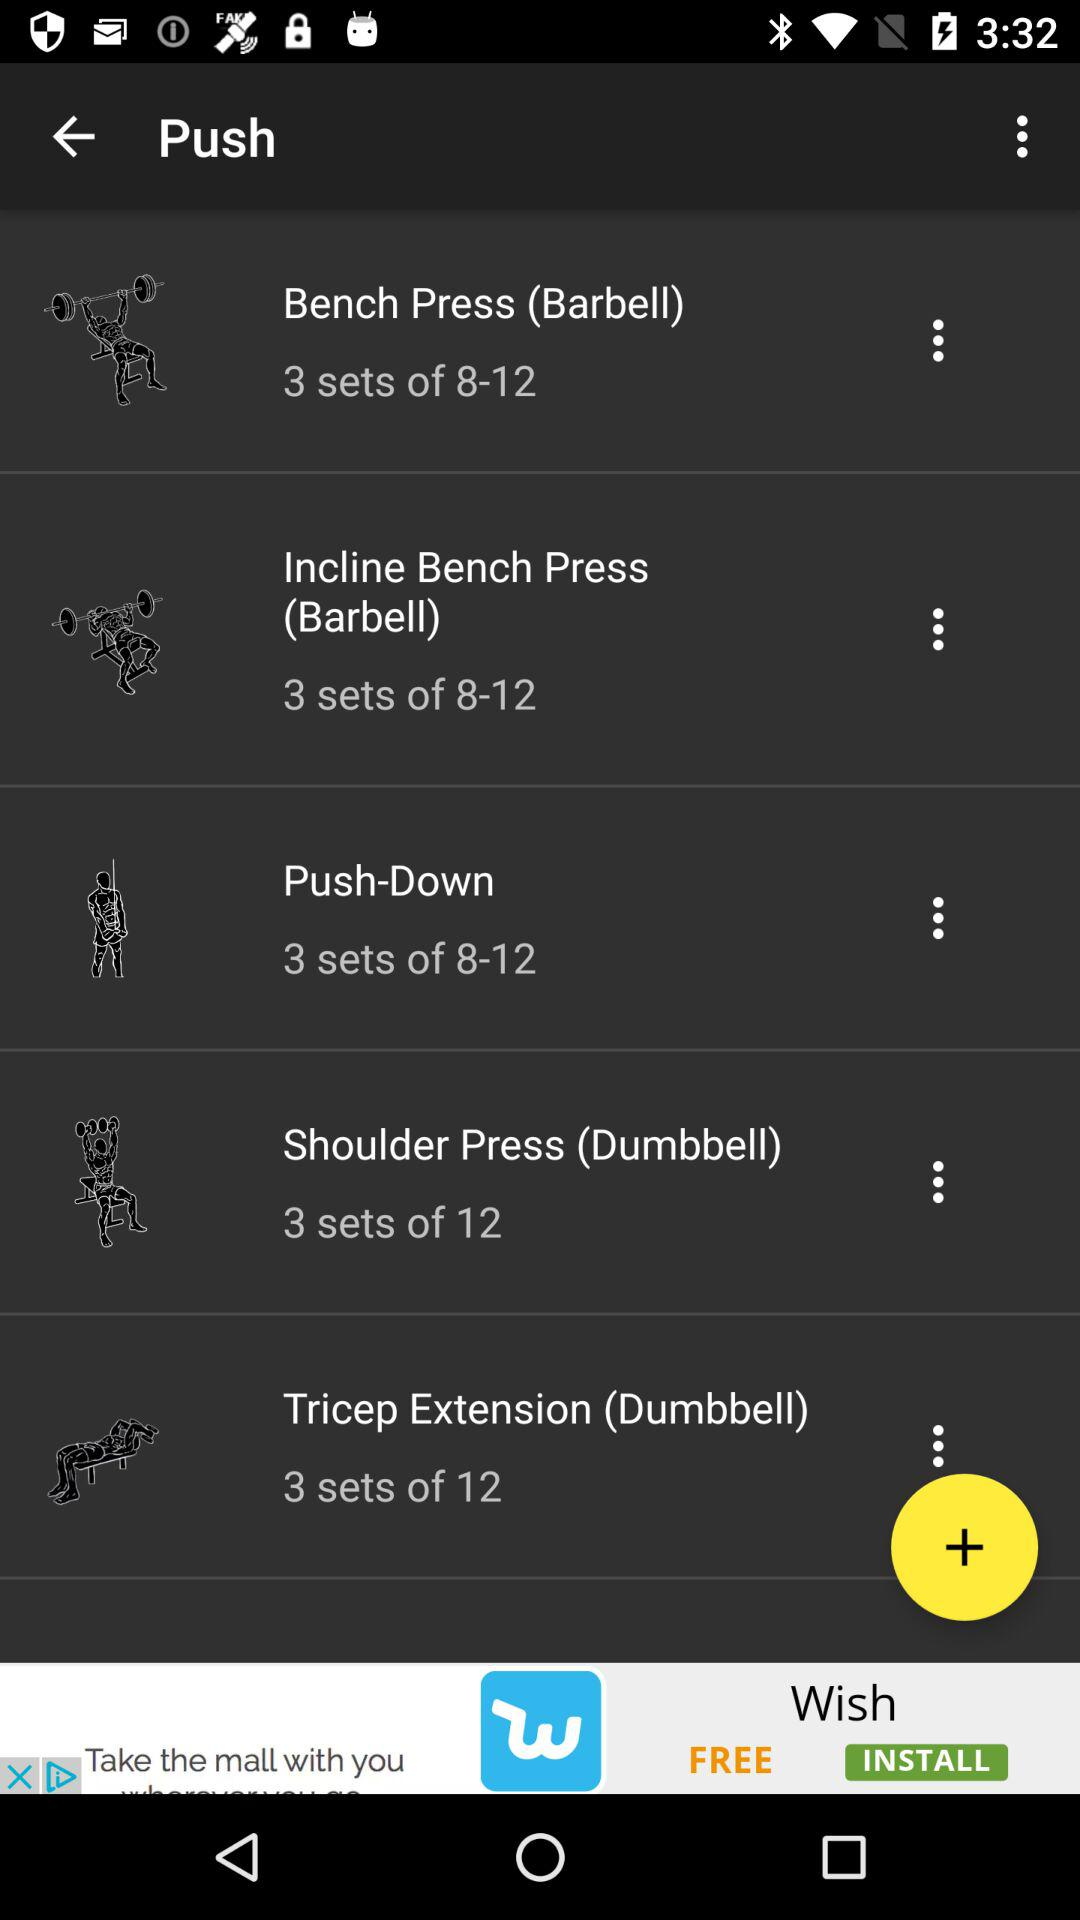What is the range of sets for Push Down? The range of sets for push down is 8 to 12. 